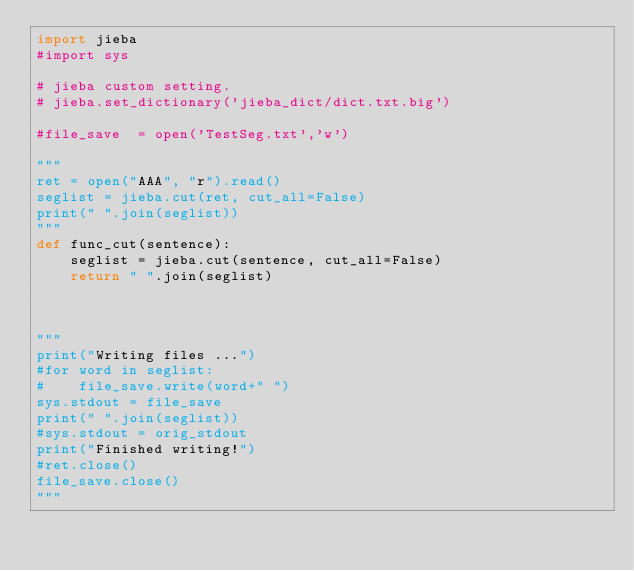Convert code to text. <code><loc_0><loc_0><loc_500><loc_500><_Python_>import jieba
#import sys

# jieba custom setting.
# jieba.set_dictionary('jieba_dict/dict.txt.big')

#file_save  = open('TestSeg.txt','w')

"""
ret = open("AAA", "r").read()
seglist = jieba.cut(ret, cut_all=False)
print(" ".join(seglist))
"""
def func_cut(sentence):
    seglist = jieba.cut(sentence, cut_all=False)
    return " ".join(seglist)



"""
print("Writing files ...")
#for word in seglist:
#    file_save.write(word+" ")
sys.stdout = file_save
print(" ".join(seglist))
#sys.stdout = orig_stdout
print("Finished writing!")
#ret.close()
file_save.close()
"""</code> 